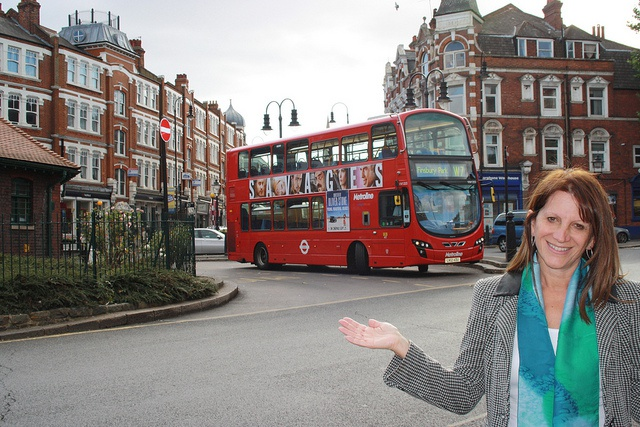Describe the objects in this image and their specific colors. I can see people in lightgray, gray, darkgray, black, and teal tones, bus in lightgray, brown, black, gray, and darkgray tones, car in lightgray, gray, darkgray, and black tones, car in lightgray, black, gray, navy, and blue tones, and car in lightgray, black, gray, and purple tones in this image. 